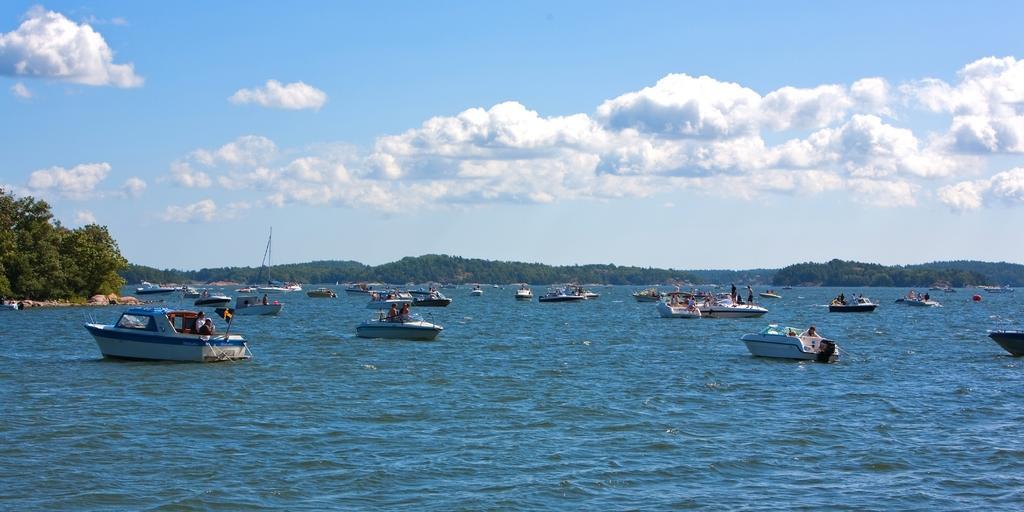Describe this image in one or two sentences. In this image I see the water on which there are number of boats and I see people on those boats and in the background I see number of trees and I see the mountains and I see the clear sky. 